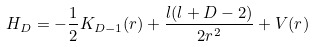<formula> <loc_0><loc_0><loc_500><loc_500>H _ { D } = - \frac { 1 } { 2 } K _ { D - 1 } ( r ) + \frac { l ( l + D - 2 ) } { 2 r ^ { 2 } } + V ( r )</formula> 